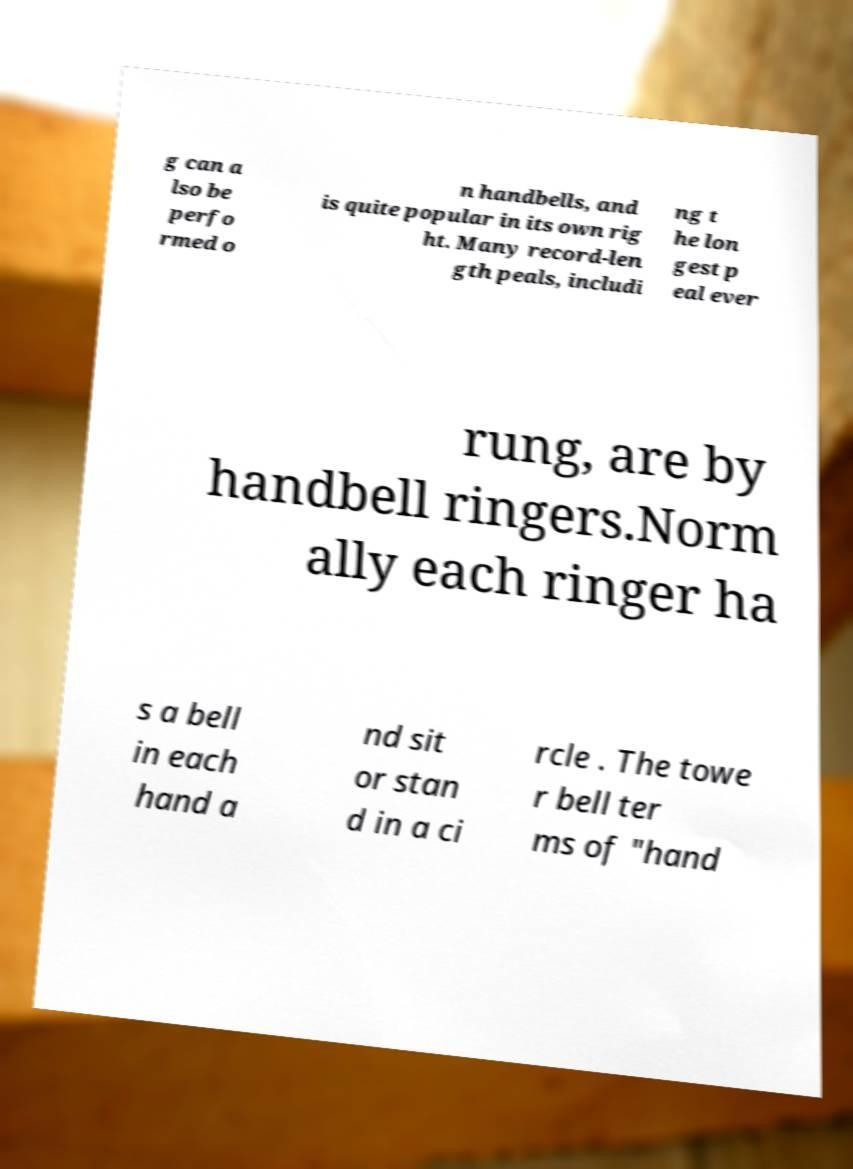I need the written content from this picture converted into text. Can you do that? g can a lso be perfo rmed o n handbells, and is quite popular in its own rig ht. Many record-len gth peals, includi ng t he lon gest p eal ever rung, are by handbell ringers.Norm ally each ringer ha s a bell in each hand a nd sit or stan d in a ci rcle . The towe r bell ter ms of "hand 